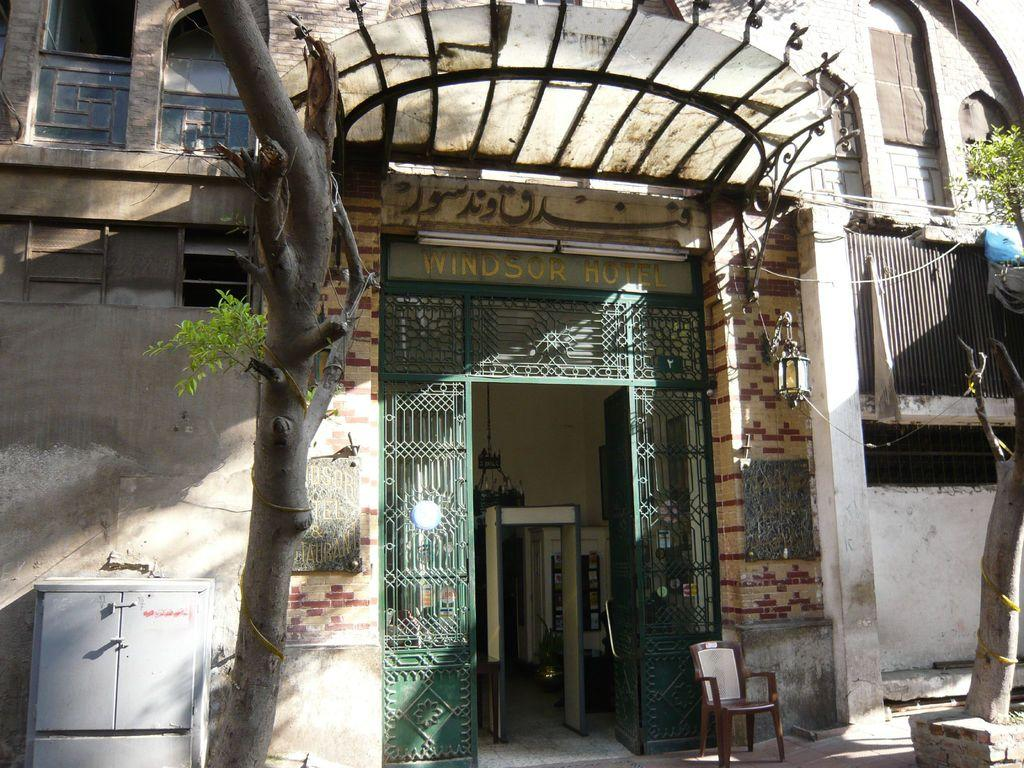<image>
Render a clear and concise summary of the photo. The front of the Windsor Hotel street view 